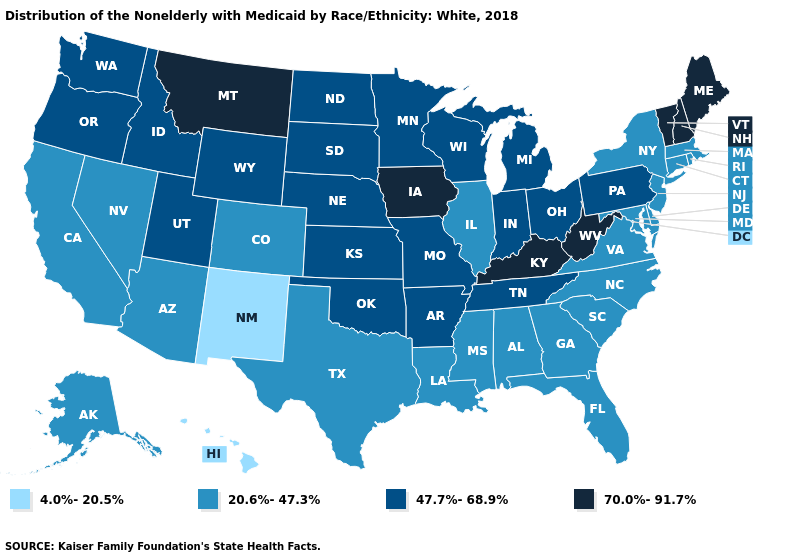Name the states that have a value in the range 20.6%-47.3%?
Quick response, please. Alabama, Alaska, Arizona, California, Colorado, Connecticut, Delaware, Florida, Georgia, Illinois, Louisiana, Maryland, Massachusetts, Mississippi, Nevada, New Jersey, New York, North Carolina, Rhode Island, South Carolina, Texas, Virginia. Does Wyoming have a lower value than Minnesota?
Be succinct. No. Which states hav the highest value in the South?
Short answer required. Kentucky, West Virginia. What is the value of Massachusetts?
Keep it brief. 20.6%-47.3%. Does Massachusetts have the lowest value in the Northeast?
Keep it brief. Yes. Name the states that have a value in the range 70.0%-91.7%?
Concise answer only. Iowa, Kentucky, Maine, Montana, New Hampshire, Vermont, West Virginia. How many symbols are there in the legend?
Keep it brief. 4. Does Montana have the highest value in the West?
Short answer required. Yes. What is the value of Nevada?
Quick response, please. 20.6%-47.3%. What is the lowest value in states that border Kansas?
Write a very short answer. 20.6%-47.3%. Does the map have missing data?
Short answer required. No. Does Alabama have the same value as South Carolina?
Short answer required. Yes. What is the lowest value in states that border Massachusetts?
Short answer required. 20.6%-47.3%. Which states have the highest value in the USA?
Concise answer only. Iowa, Kentucky, Maine, Montana, New Hampshire, Vermont, West Virginia. What is the value of Kentucky?
Concise answer only. 70.0%-91.7%. 